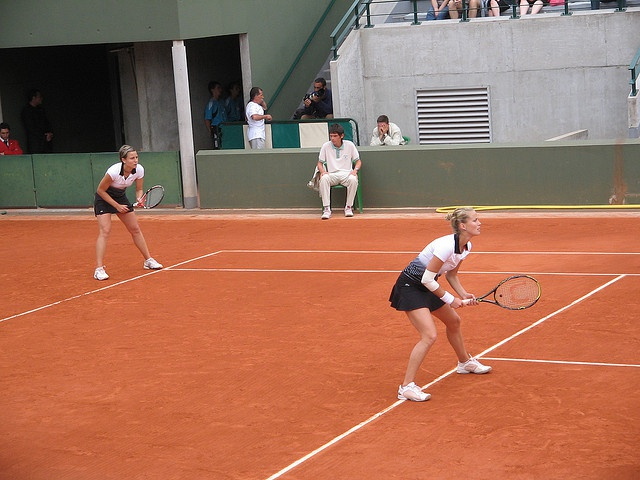Describe the objects in this image and their specific colors. I can see people in darkgreen, black, lavender, brown, and lightpink tones, people in darkgreen, brown, black, gray, and salmon tones, people in darkgreen, lightgray, pink, darkgray, and brown tones, people in darkgreen, black, teal, and maroon tones, and tennis racket in darkgreen and salmon tones in this image. 